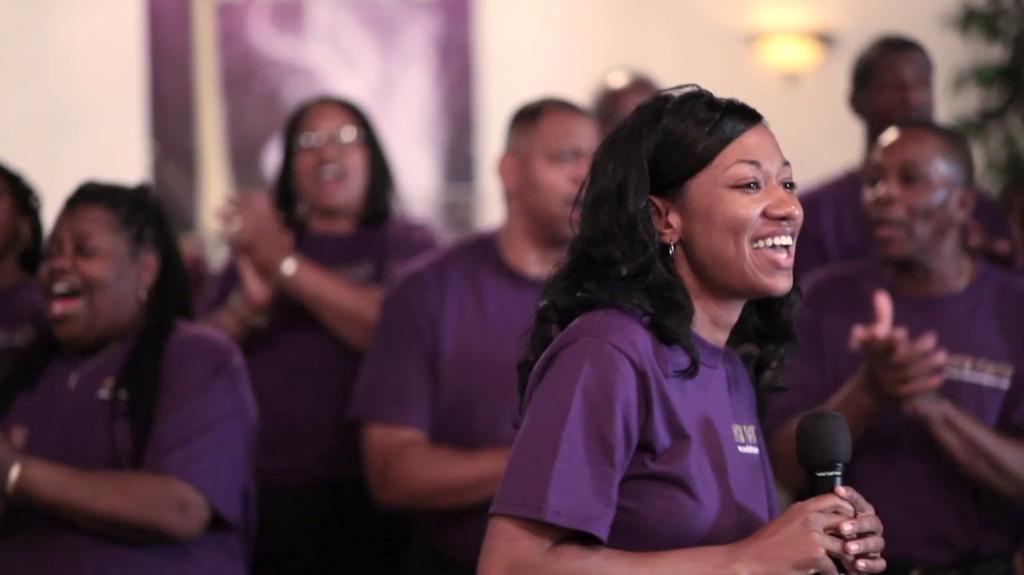Please provide a concise description of this image. In this image there are groups of people. In front there is a woman smiling and holding a mic at the background there is wall and a light. 